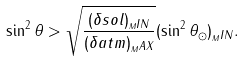Convert formula to latex. <formula><loc_0><loc_0><loc_500><loc_500>\sin ^ { 2 } \theta > \sqrt { \frac { ( \delta s o l ) _ { _ { M } I N } } { ( \delta a t m ) _ { _ { M } A X } } } ( \sin ^ { 2 } \theta _ { \odot } ) _ { _ { M } I N } .</formula> 